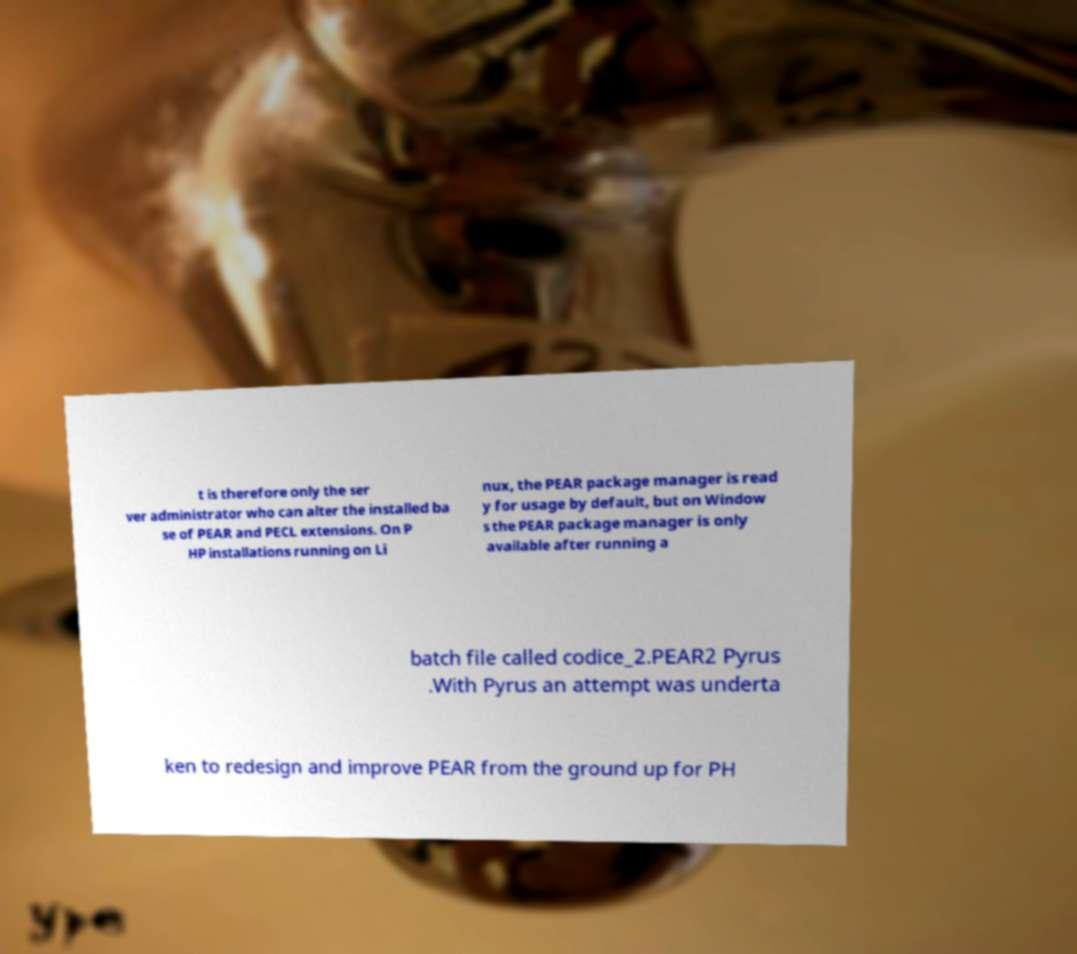There's text embedded in this image that I need extracted. Can you transcribe it verbatim? t is therefore only the ser ver administrator who can alter the installed ba se of PEAR and PECL extensions. On P HP installations running on Li nux, the PEAR package manager is read y for usage by default, but on Window s the PEAR package manager is only available after running a batch file called codice_2.PEAR2 Pyrus .With Pyrus an attempt was underta ken to redesign and improve PEAR from the ground up for PH 